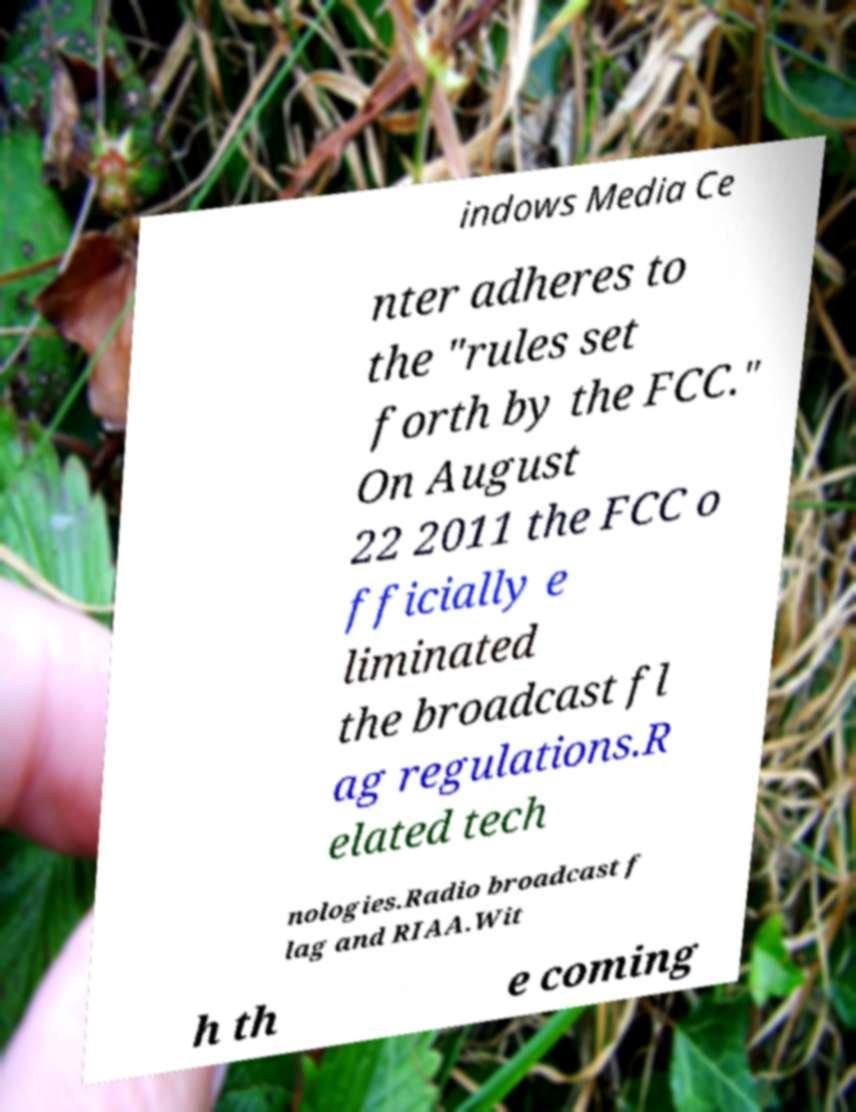Could you assist in decoding the text presented in this image and type it out clearly? indows Media Ce nter adheres to the "rules set forth by the FCC." On August 22 2011 the FCC o fficially e liminated the broadcast fl ag regulations.R elated tech nologies.Radio broadcast f lag and RIAA.Wit h th e coming 